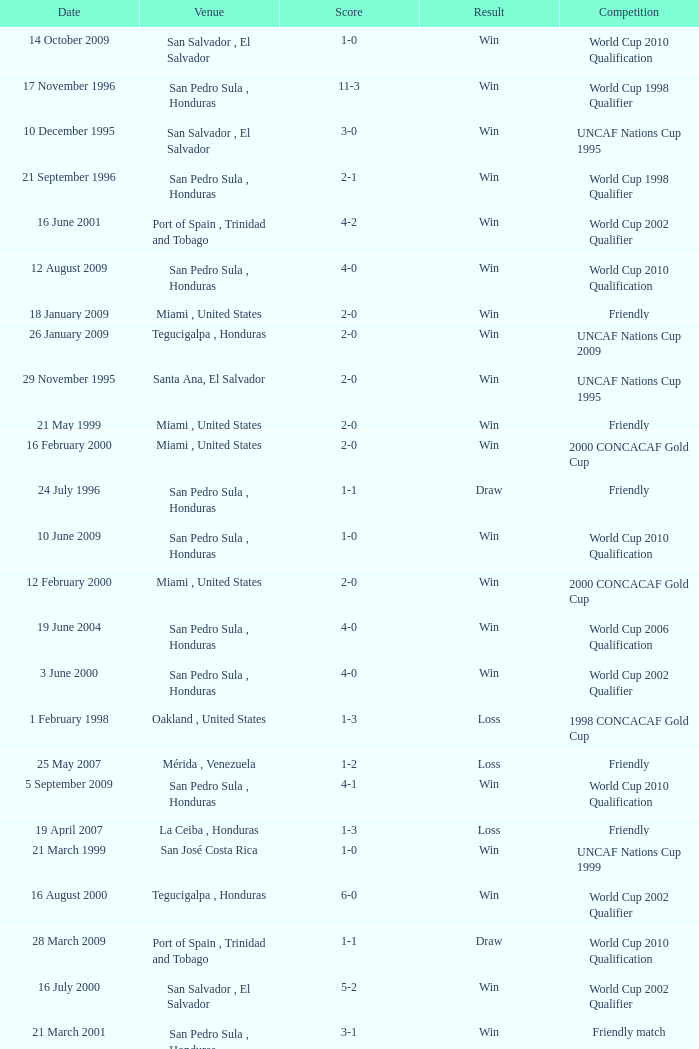Name the date of the uncaf nations cup 2009 26 January 2009. 